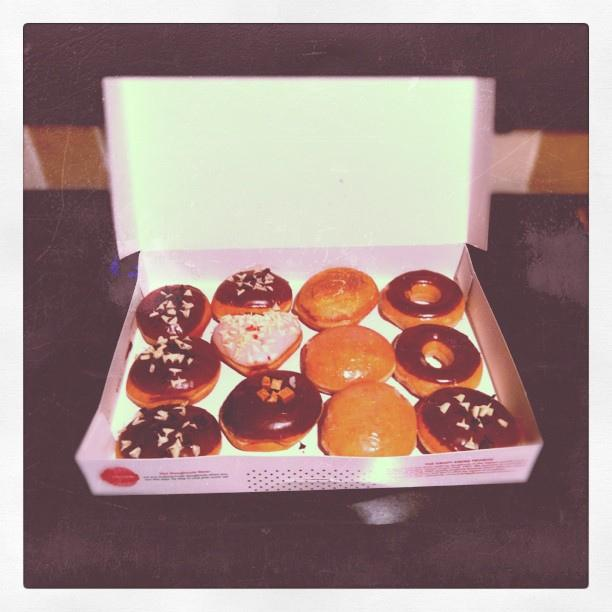What is the box made of?

Choices:
A) glass
B) steel
C) paper
D) plastic paper 